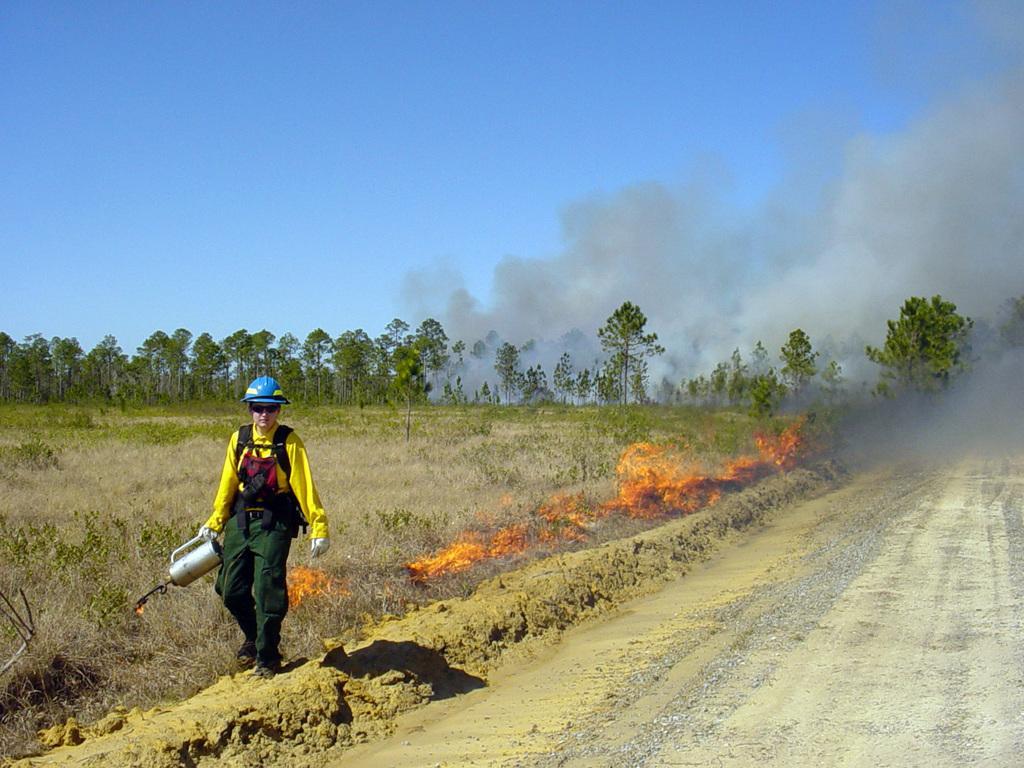How would you summarize this image in a sentence or two? In this image we can see a man is walking. He is wearing yellow and green color dress with blue helmet and holding something in his hand. Background of the image trees are there and fire is there. Right side of the image smoke is present. The sky is in blue color. 